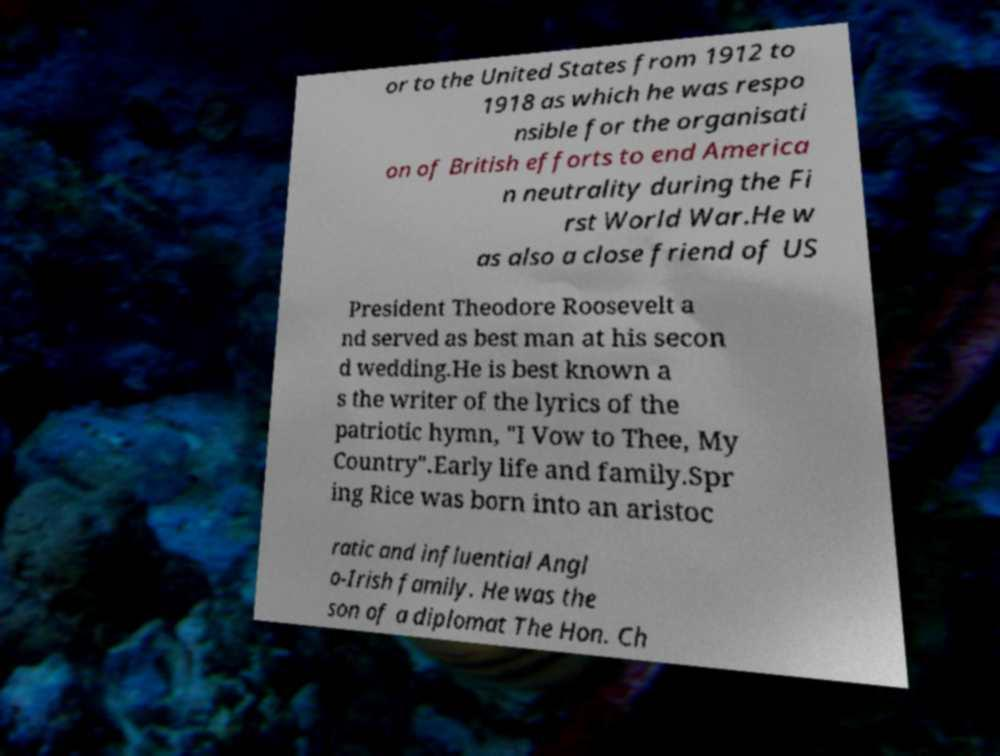I need the written content from this picture converted into text. Can you do that? or to the United States from 1912 to 1918 as which he was respo nsible for the organisati on of British efforts to end America n neutrality during the Fi rst World War.He w as also a close friend of US President Theodore Roosevelt a nd served as best man at his secon d wedding.He is best known a s the writer of the lyrics of the patriotic hymn, "I Vow to Thee, My Country".Early life and family.Spr ing Rice was born into an aristoc ratic and influential Angl o-Irish family. He was the son of a diplomat The Hon. Ch 